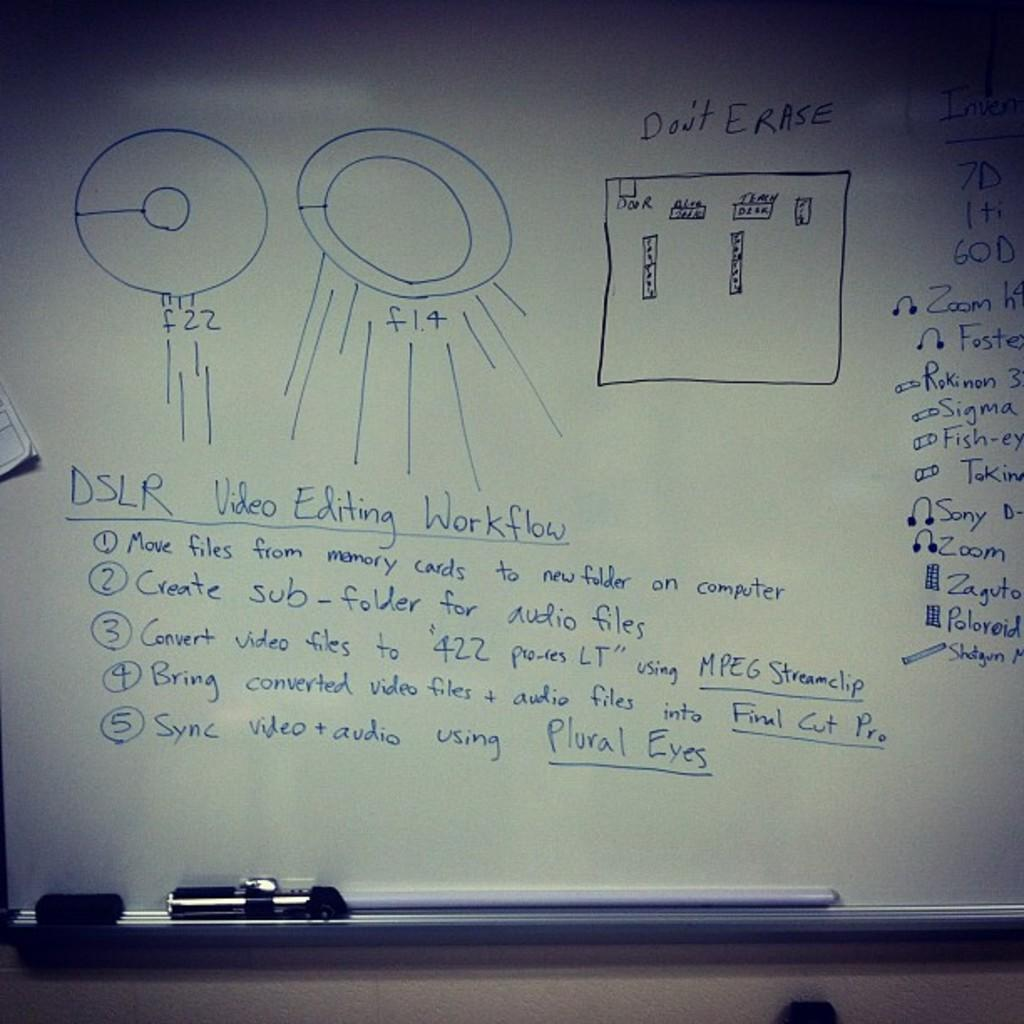<image>
Offer a succinct explanation of the picture presented. The whiteboard has a diagram depicting DSLR video editing workflow. 